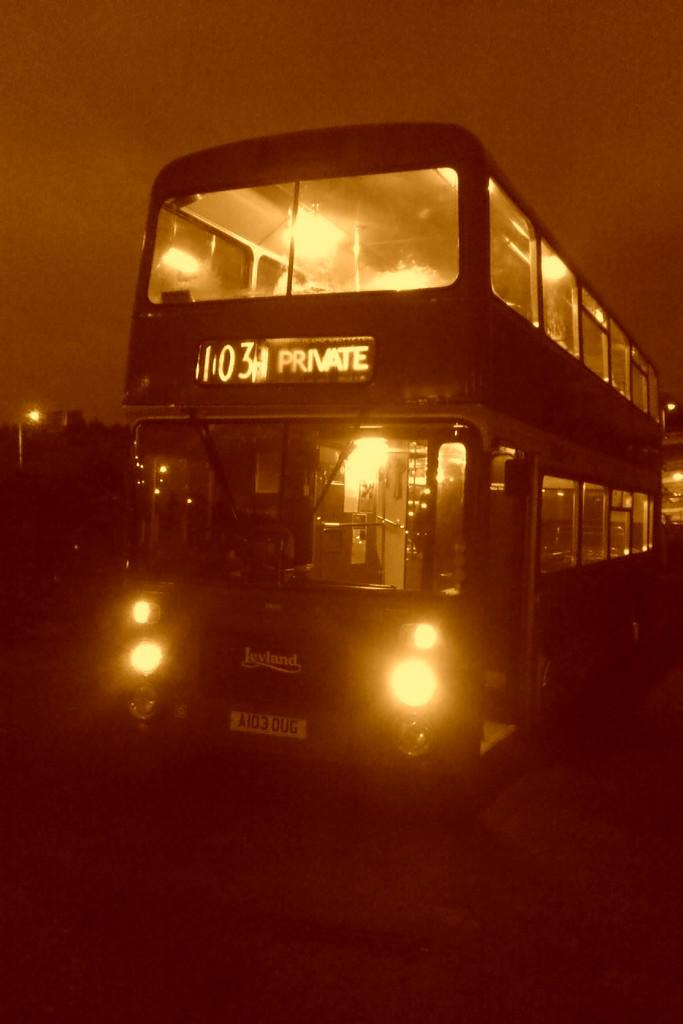What is the main subject of the image? The main subject of the image is a bus. What is the bus doing in the image? The bus is moving on the road in the image. What features can be seen inside the bus? There are lights and a board visible inside the bus. What can be seen in the background of the image? The sky is visible in the background of the image. What type of jam is being served on the bus in the image? There is no jam present in the image; it features a bus moving on the road with lights and a board inside. 